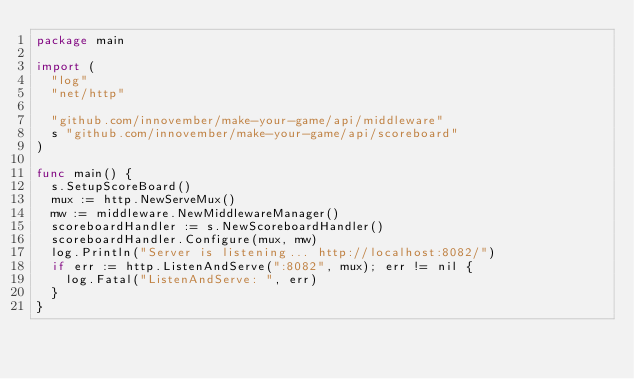Convert code to text. <code><loc_0><loc_0><loc_500><loc_500><_Go_>package main

import (
	"log"
	"net/http"

	"github.com/innovember/make-your-game/api/middleware"
	s "github.com/innovember/make-your-game/api/scoreboard"
)

func main() {
	s.SetupScoreBoard()
	mux := http.NewServeMux()
	mw := middleware.NewMiddlewareManager()
	scoreboardHandler := s.NewScoreboardHandler()
	scoreboardHandler.Configure(mux, mw)
	log.Println("Server is listening... http://localhost:8082/")
	if err := http.ListenAndServe(":8082", mux); err != nil {
		log.Fatal("ListenAndServe: ", err)
	}
}
</code> 